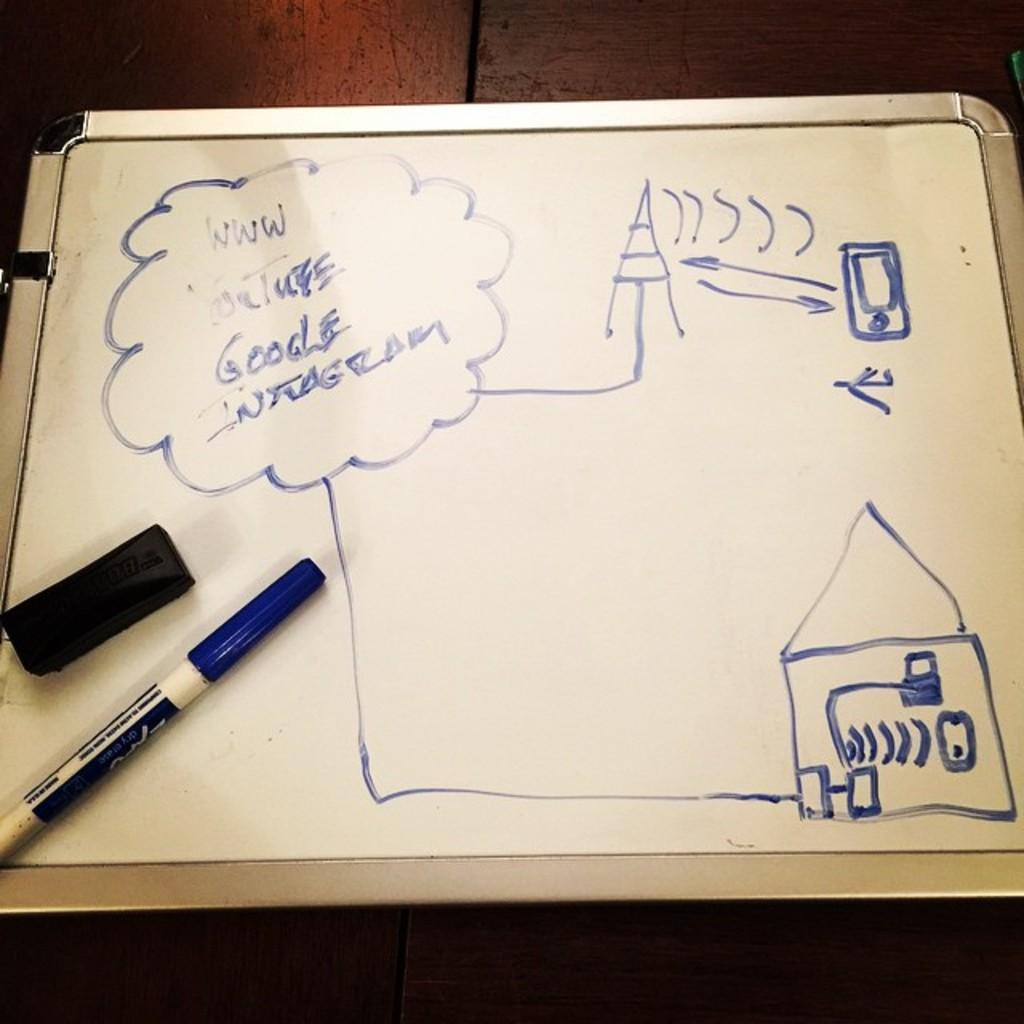<image>
Render a clear and concise summary of the photo. Images drawn on a white board include the words Google and You Tube. 